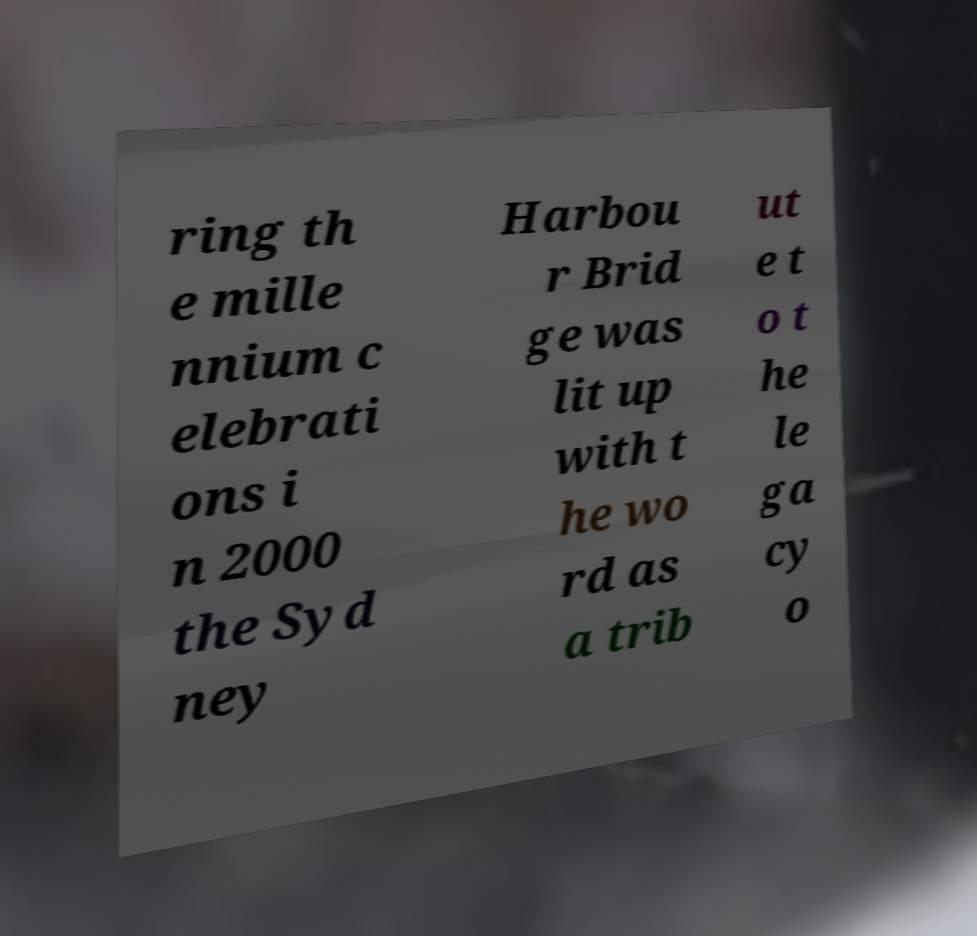Please read and relay the text visible in this image. What does it say? ring th e mille nnium c elebrati ons i n 2000 the Syd ney Harbou r Brid ge was lit up with t he wo rd as a trib ut e t o t he le ga cy o 